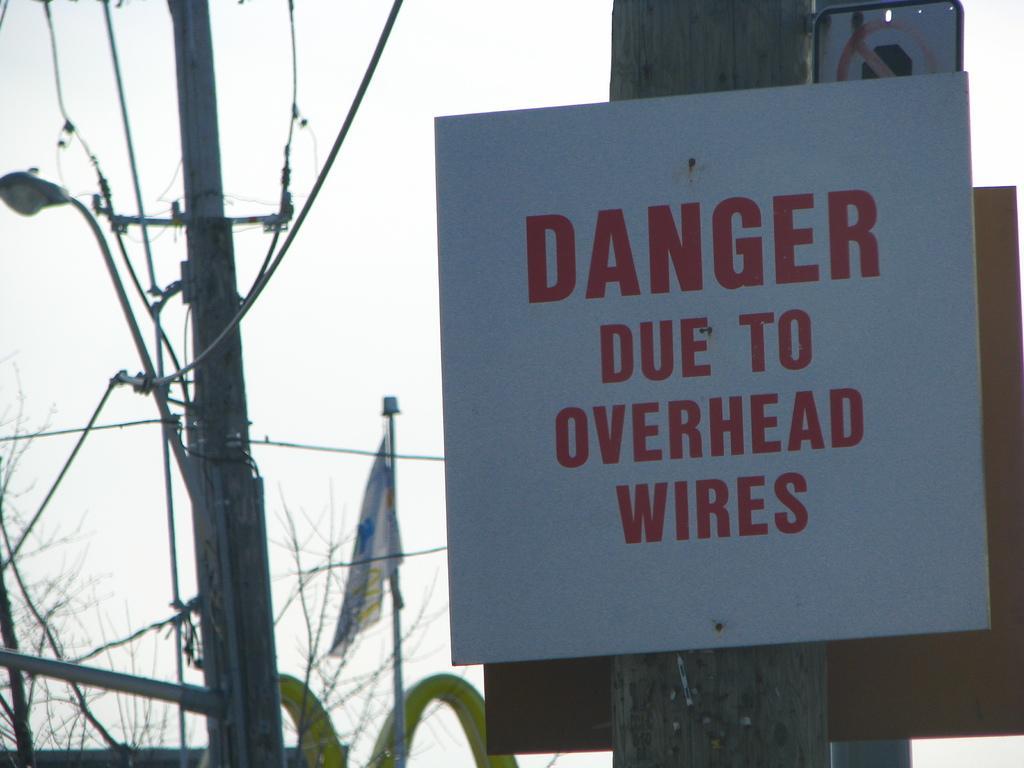In one or two sentences, can you explain what this image depicts? In this image we can see electrical pole, flag, trees and we can also see a board with some text written on it. 